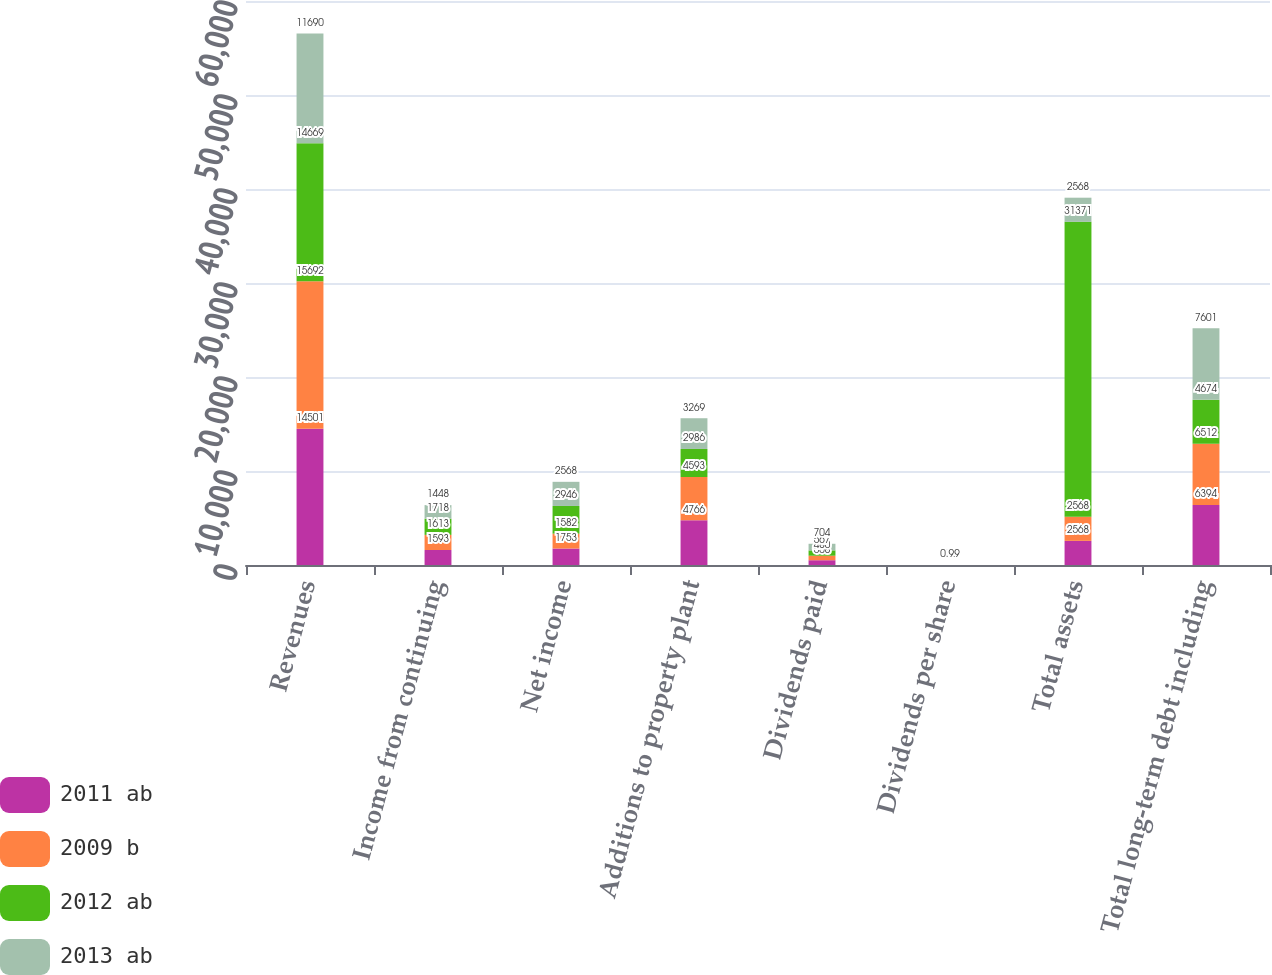<chart> <loc_0><loc_0><loc_500><loc_500><stacked_bar_chart><ecel><fcel>Revenues<fcel>Income from continuing<fcel>Net income<fcel>Additions to property plant<fcel>Dividends paid<fcel>Dividends per share<fcel>Total assets<fcel>Total long-term debt including<nl><fcel>2011 ab<fcel>14501<fcel>1593<fcel>1753<fcel>4766<fcel>508<fcel>0.72<fcel>2568<fcel>6394<nl><fcel>2009 b<fcel>15692<fcel>1613<fcel>1582<fcel>4593<fcel>480<fcel>0.68<fcel>2568<fcel>6512<nl><fcel>2012 ab<fcel>14669<fcel>1718<fcel>2946<fcel>2986<fcel>567<fcel>0.8<fcel>31371<fcel>4674<nl><fcel>2013 ab<fcel>11690<fcel>1448<fcel>2568<fcel>3269<fcel>704<fcel>0.99<fcel>2568<fcel>7601<nl></chart> 